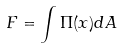<formula> <loc_0><loc_0><loc_500><loc_500>F = \int \Pi ( x ) d A</formula> 